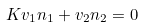<formula> <loc_0><loc_0><loc_500><loc_500>K v _ { 1 } n _ { 1 } + v _ { 2 } n _ { 2 } = 0</formula> 